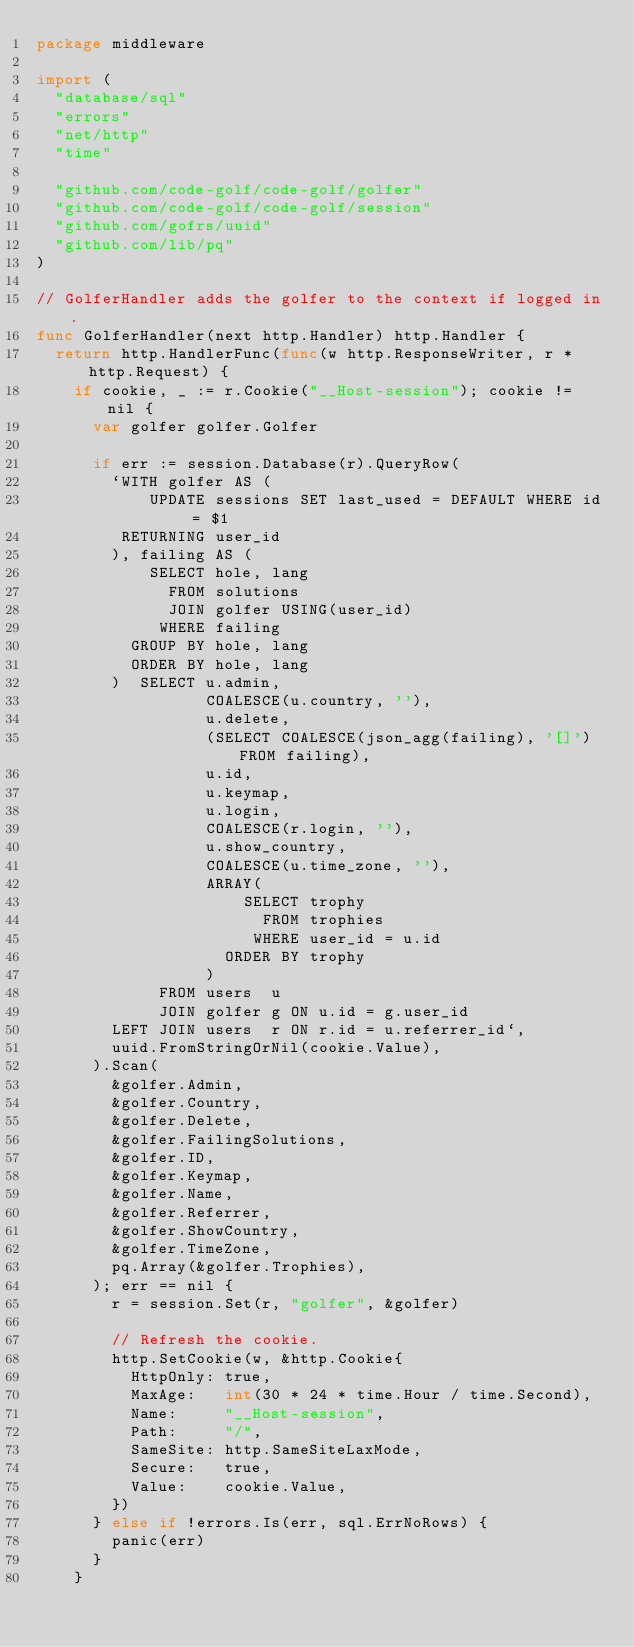<code> <loc_0><loc_0><loc_500><loc_500><_Go_>package middleware

import (
	"database/sql"
	"errors"
	"net/http"
	"time"

	"github.com/code-golf/code-golf/golfer"
	"github.com/code-golf/code-golf/session"
	"github.com/gofrs/uuid"
	"github.com/lib/pq"
)

// GolferHandler adds the golfer to the context if logged in.
func GolferHandler(next http.Handler) http.Handler {
	return http.HandlerFunc(func(w http.ResponseWriter, r *http.Request) {
		if cookie, _ := r.Cookie("__Host-session"); cookie != nil {
			var golfer golfer.Golfer

			if err := session.Database(r).QueryRow(
				`WITH golfer AS (
				    UPDATE sessions SET last_used = DEFAULT WHERE id = $1
				 RETURNING user_id
				), failing AS (
				    SELECT hole, lang
				      FROM solutions
				      JOIN golfer USING(user_id)
				     WHERE failing
				  GROUP BY hole, lang
				  ORDER BY hole, lang
				)  SELECT u.admin,
				          COALESCE(u.country, ''),
				          u.delete,
				          (SELECT COALESCE(json_agg(failing), '[]') FROM failing),
				          u.id,
				          u.keymap,
				          u.login,
				          COALESCE(r.login, ''),
				          u.show_country,
				          COALESCE(u.time_zone, ''),
				          ARRAY(
				              SELECT trophy
				                FROM trophies
				               WHERE user_id = u.id
				            ORDER BY trophy
				          )
				     FROM users  u
				     JOIN golfer g ON u.id = g.user_id
				LEFT JOIN users  r ON r.id = u.referrer_id`,
				uuid.FromStringOrNil(cookie.Value),
			).Scan(
				&golfer.Admin,
				&golfer.Country,
				&golfer.Delete,
				&golfer.FailingSolutions,
				&golfer.ID,
				&golfer.Keymap,
				&golfer.Name,
				&golfer.Referrer,
				&golfer.ShowCountry,
				&golfer.TimeZone,
				pq.Array(&golfer.Trophies),
			); err == nil {
				r = session.Set(r, "golfer", &golfer)

				// Refresh the cookie.
				http.SetCookie(w, &http.Cookie{
					HttpOnly: true,
					MaxAge:   int(30 * 24 * time.Hour / time.Second),
					Name:     "__Host-session",
					Path:     "/",
					SameSite: http.SameSiteLaxMode,
					Secure:   true,
					Value:    cookie.Value,
				})
			} else if !errors.Is(err, sql.ErrNoRows) {
				panic(err)
			}
		}
</code> 